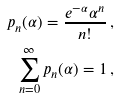Convert formula to latex. <formula><loc_0><loc_0><loc_500><loc_500>p _ { n } ( \alpha ) = \frac { e ^ { - \alpha } \alpha ^ { n } } { n ! } \, , \\ \sum _ { n = 0 } ^ { \infty } p _ { n } ( \alpha ) = 1 \, ,</formula> 